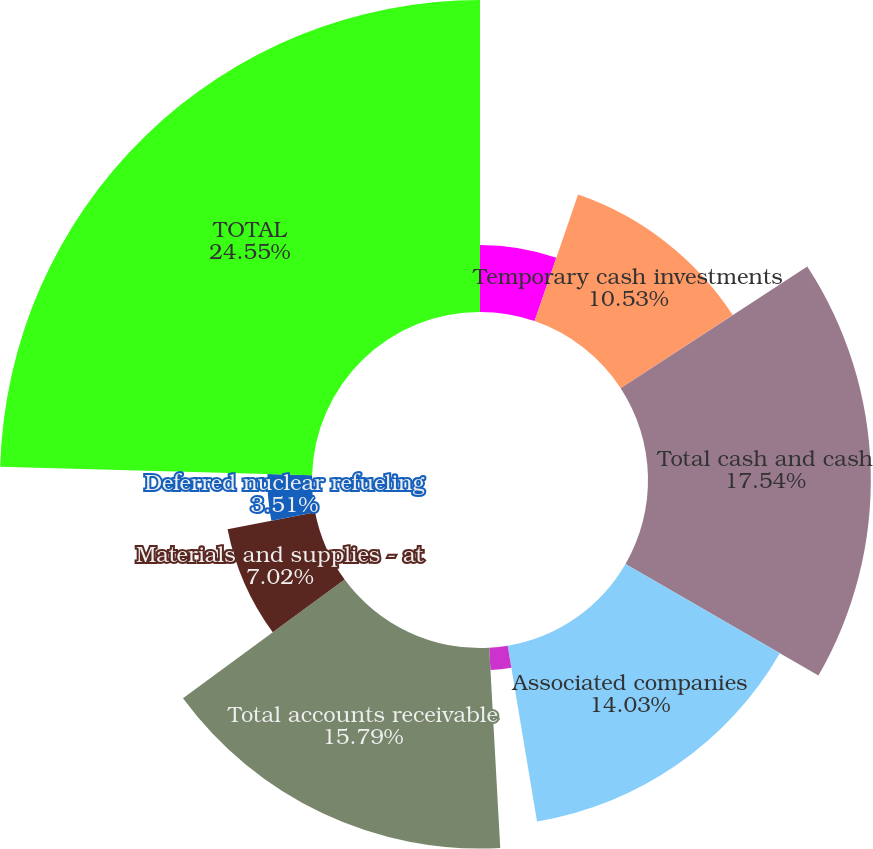Convert chart to OTSL. <chart><loc_0><loc_0><loc_500><loc_500><pie_chart><fcel>Cash<fcel>Temporary cash investments<fcel>Total cash and cash<fcel>Associated companies<fcel>Other<fcel>Total accounts receivable<fcel>Materials and supplies - at<fcel>Deferred nuclear refueling<fcel>Prepayments and other<fcel>TOTAL<nl><fcel>5.27%<fcel>10.53%<fcel>17.54%<fcel>14.03%<fcel>1.76%<fcel>15.79%<fcel>7.02%<fcel>3.51%<fcel>0.0%<fcel>24.56%<nl></chart> 